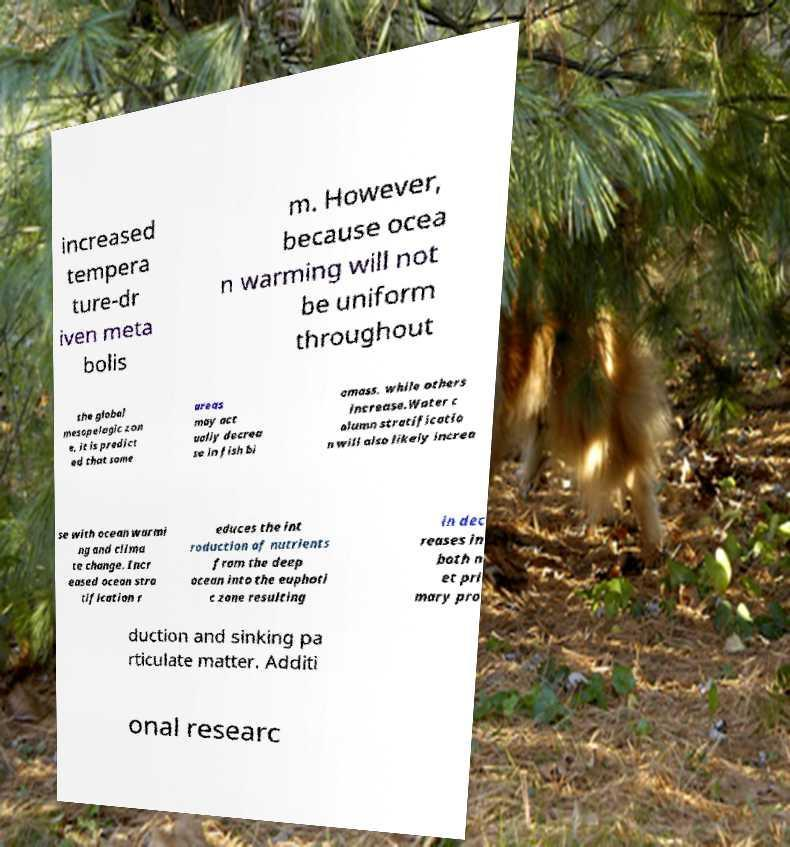Please identify and transcribe the text found in this image. increased tempera ture-dr iven meta bolis m. However, because ocea n warming will not be uniform throughout the global mesopelagic zon e, it is predict ed that some areas may act ually decrea se in fish bi omass, while others increase.Water c olumn stratificatio n will also likely increa se with ocean warmi ng and clima te change. Incr eased ocean stra tification r educes the int roduction of nutrients from the deep ocean into the euphoti c zone resulting in dec reases in both n et pri mary pro duction and sinking pa rticulate matter. Additi onal researc 